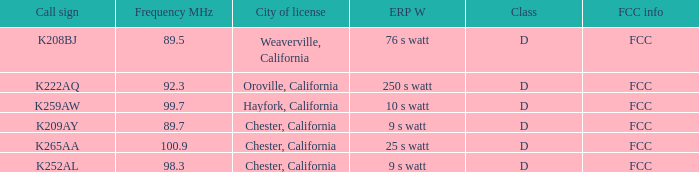Name the call sign with frequency of 89.5 K208BJ. 